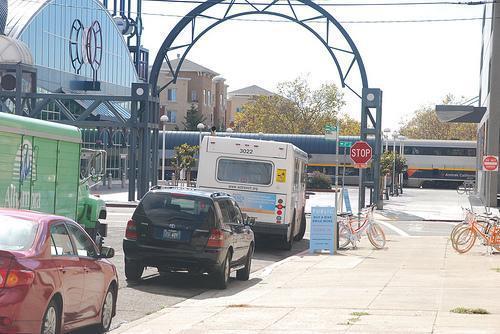How many stop signs are there?
Give a very brief answer. 1. 